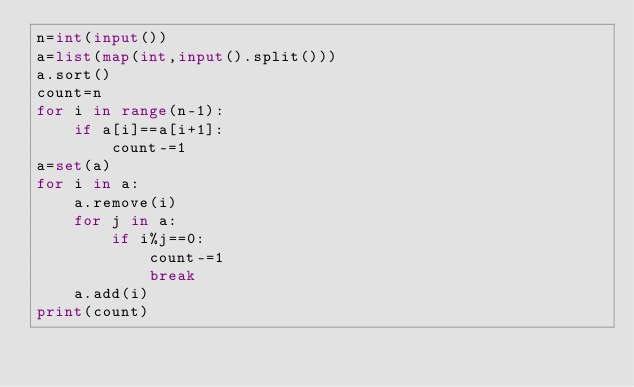Convert code to text. <code><loc_0><loc_0><loc_500><loc_500><_Python_>n=int(input())
a=list(map(int,input().split()))
a.sort()
count=n
for i in range(n-1):
    if a[i]==a[i+1]:
        count-=1
a=set(a)
for i in a:
    a.remove(i)
    for j in a:
        if i%j==0:
            count-=1
            break
    a.add(i)
print(count)

</code> 